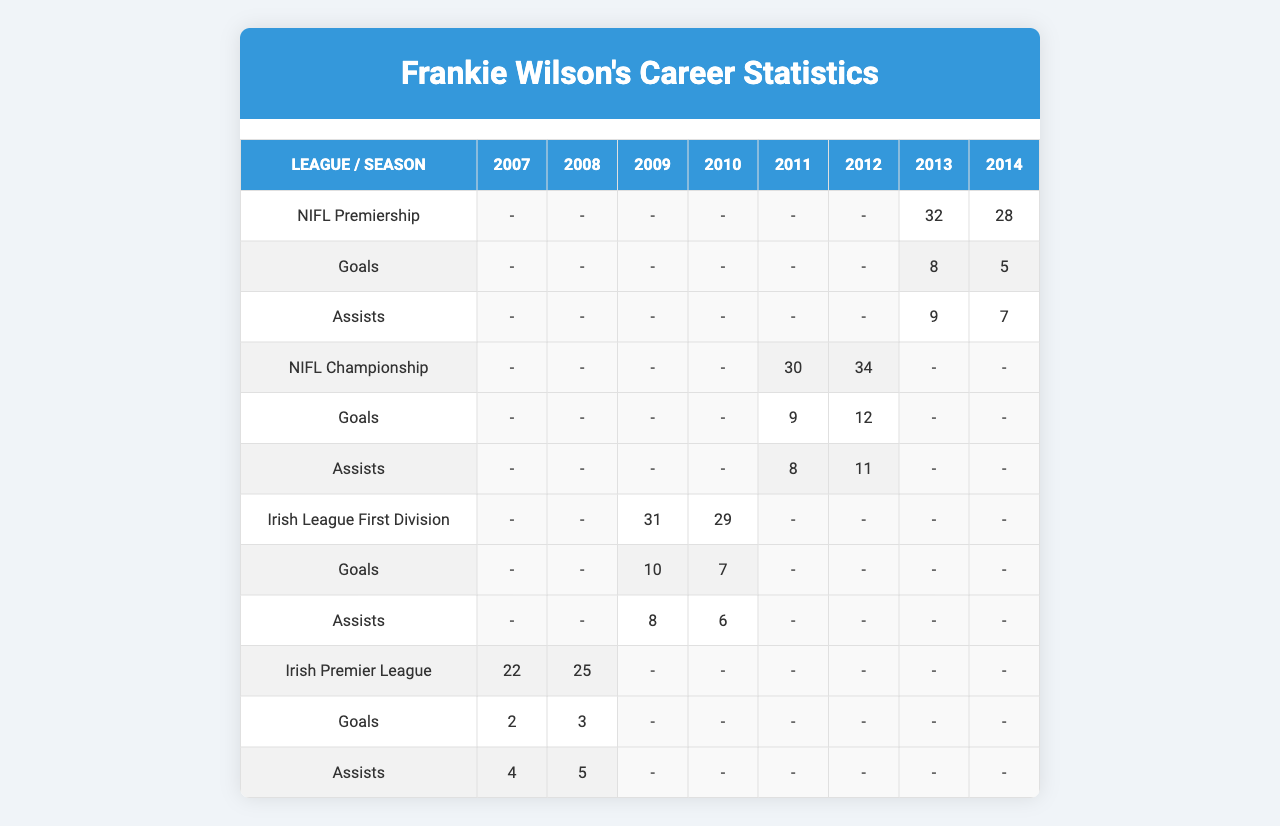What were Frankie Wilson's total goals in the NIFL Premiership? In the NIFL Premiership, Frankie Wilson scored 5 goals in 2014 and 8 goals in 2013. Adding these gives a total of 5 + 8 = 13 goals.
Answer: 13 How many assists did Frankie Wilson provide in the Irish League First Division for the year 2010? In the Irish League First Division for 2010, Frankie Wilson provided 6 assists.
Answer: 6 What was the average number of appearances Frankie Wilson made per season in the NIFL Championship? In the NIFL Championship, he made 34 appearances in 2012 and 30 in 2011, totaling 64 appearances over 2 seasons. The average is 64 / 2 = 32.
Answer: 32 Did Frankie Wilson play more seasons in the NIFL Premiership or the NIFL Championship? Frankie Wilson played in the NIFL Premiership for 2 seasons (2013, 2014) and in the NIFL Championship for 2 seasons (2011, 2012). Therefore, he played the same number of seasons in both leagues.
Answer: Yes In which season did Frankie Wilson achieve the highest number of assists and how many did he have? The highest number of assists was in the NIFL Championship in 2012, where he recorded 11 assists.
Answer: 11 in 2012 What is the total number of goals scored by Frankie Wilson across all leagues from 2007 to 2014? Summing all goals: 2 (2007) + 3 (2008) + 10 (2009) + 7 (2010) + 9 (2011) + 12 (2012) + 8 (2013) + 5 (2014) gives 2 + 3 + 10 + 7 + 9 + 12 + 8 + 5 = 56 goals.
Answer: 56 Which league had the highest number of goals scored by Frankie Wilson in a single season, and how many goals did he score? The highest number of goals was 12 in the NIFL Championship in 2012.
Answer: NIFL Championship, 12 goals What is the difference in total appearances between Frankie Wilson's best and worst seasons? His best season was 2012 in the NIFL Championship with 34 appearances, and his worst was 2007 in the Irish Premier League with 22 appearances. The difference is 34 - 22 = 12 appearances.
Answer: 12 How many assists did Frankie Wilson register in the Irish Premier League over the two seasons he played? Over the two seasons, he had 4 assists in 2007 and 5 assists in 2008, totaling 4 + 5 = 9 assists.
Answer: 9 What percentage of Frankie Wilson's total appearances were in the NIFL Premiership? He had 28 appearances in 2014 and 32 in 2013 (total 60) and 60 appearances out of a total of 28 + 32 + 34 + 30 + 29 + 31 + 25 + 22 =  31 appearances in total. The percentage is (60 / 31) * 100 = ~19.35%.
Answer: ~19.35% 